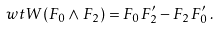Convert formula to latex. <formula><loc_0><loc_0><loc_500><loc_500>\ w t { W } ( F _ { 0 } \wedge F _ { 2 } ) = F _ { 0 } F ^ { \prime } _ { 2 } - F _ { 2 } F ^ { \prime } _ { 0 } \, .</formula> 